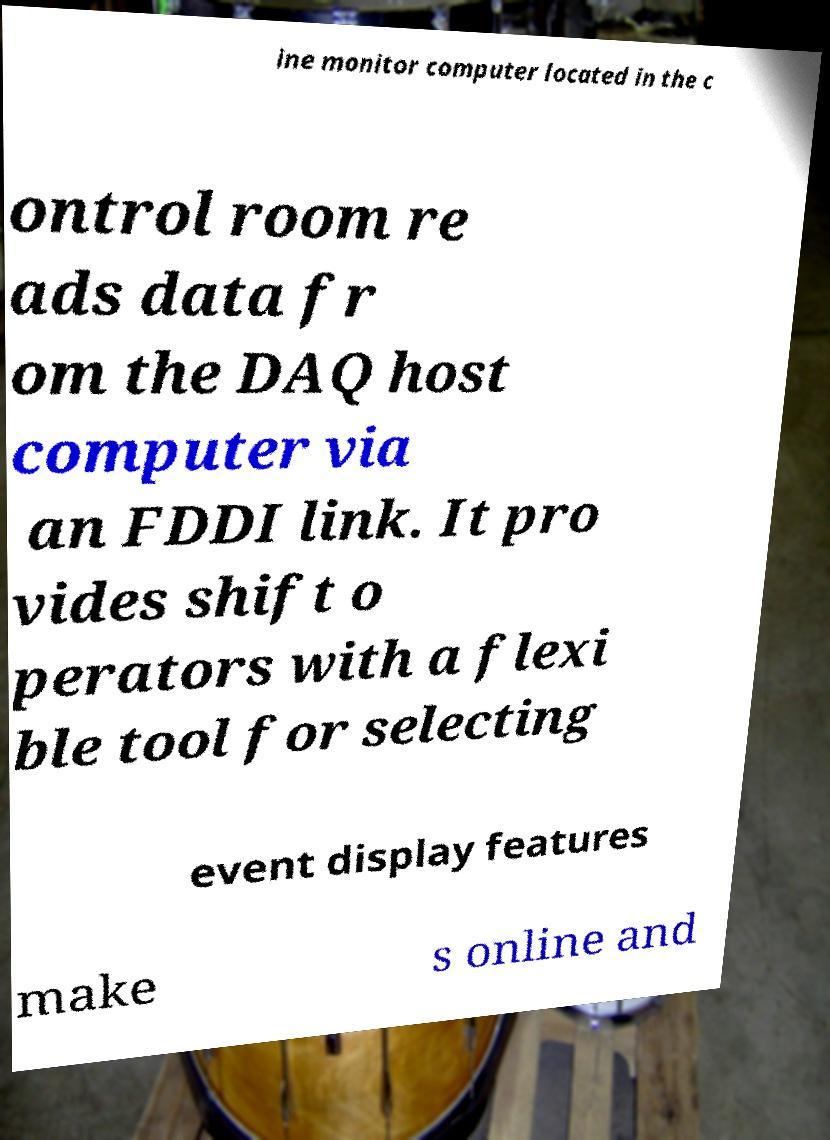Can you accurately transcribe the text from the provided image for me? ine monitor computer located in the c ontrol room re ads data fr om the DAQ host computer via an FDDI link. It pro vides shift o perators with a flexi ble tool for selecting event display features make s online and 